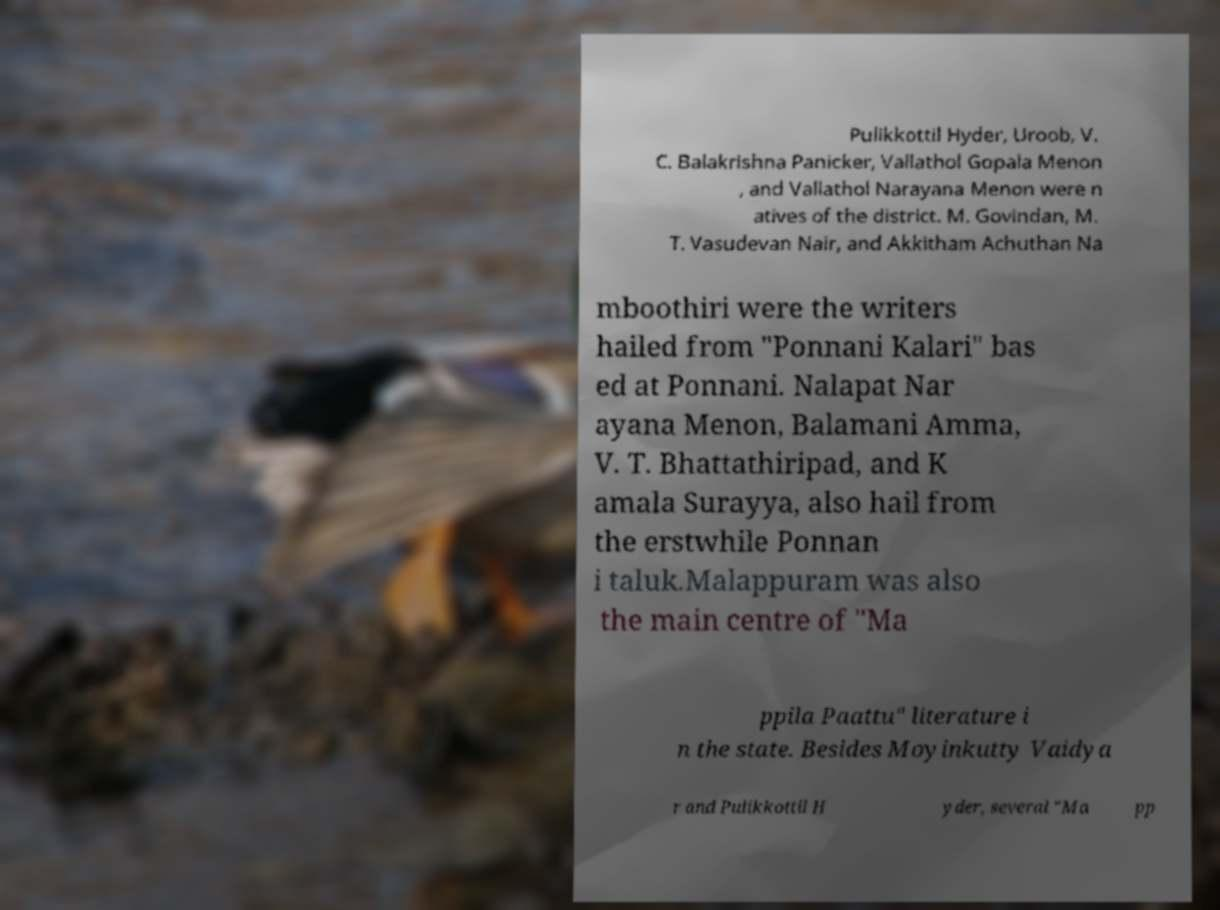Could you assist in decoding the text presented in this image and type it out clearly? Pulikkottil Hyder, Uroob, V. C. Balakrishna Panicker, Vallathol Gopala Menon , and Vallathol Narayana Menon were n atives of the district. M. Govindan, M. T. Vasudevan Nair, and Akkitham Achuthan Na mboothiri were the writers hailed from "Ponnani Kalari" bas ed at Ponnani. Nalapat Nar ayana Menon, Balamani Amma, V. T. Bhattathiripad, and K amala Surayya, also hail from the erstwhile Ponnan i taluk.Malappuram was also the main centre of "Ma ppila Paattu" literature i n the state. Besides Moyinkutty Vaidya r and Pulikkottil H yder, several "Ma pp 